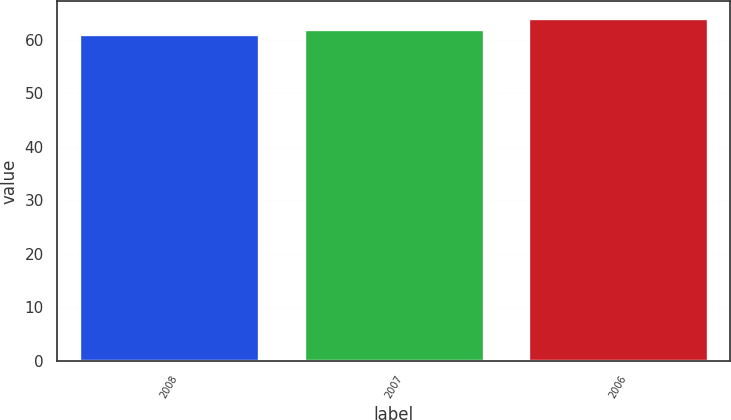Convert chart to OTSL. <chart><loc_0><loc_0><loc_500><loc_500><bar_chart><fcel>2008<fcel>2007<fcel>2006<nl><fcel>61<fcel>62<fcel>64<nl></chart> 